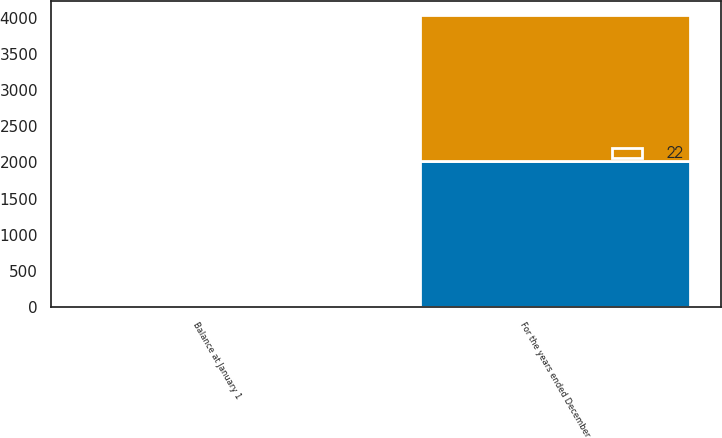Convert chart. <chart><loc_0><loc_0><loc_500><loc_500><stacked_bar_chart><ecel><fcel>For the years ended December<fcel>Balance at January 1<nl><fcel>nan<fcel>2018<fcel>22<nl><fcel>22<fcel>2017<fcel>22<nl></chart> 